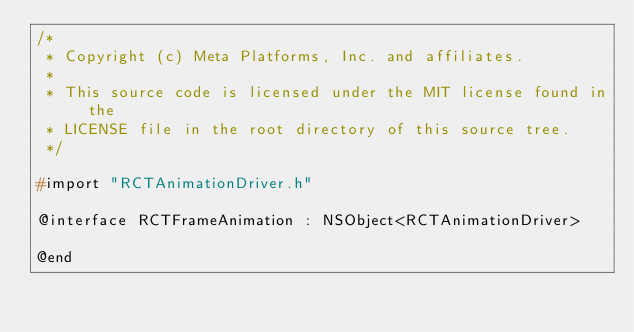<code> <loc_0><loc_0><loc_500><loc_500><_C_>/*
 * Copyright (c) Meta Platforms, Inc. and affiliates.
 *
 * This source code is licensed under the MIT license found in the
 * LICENSE file in the root directory of this source tree.
 */

#import "RCTAnimationDriver.h"

@interface RCTFrameAnimation : NSObject<RCTAnimationDriver>

@end
</code> 